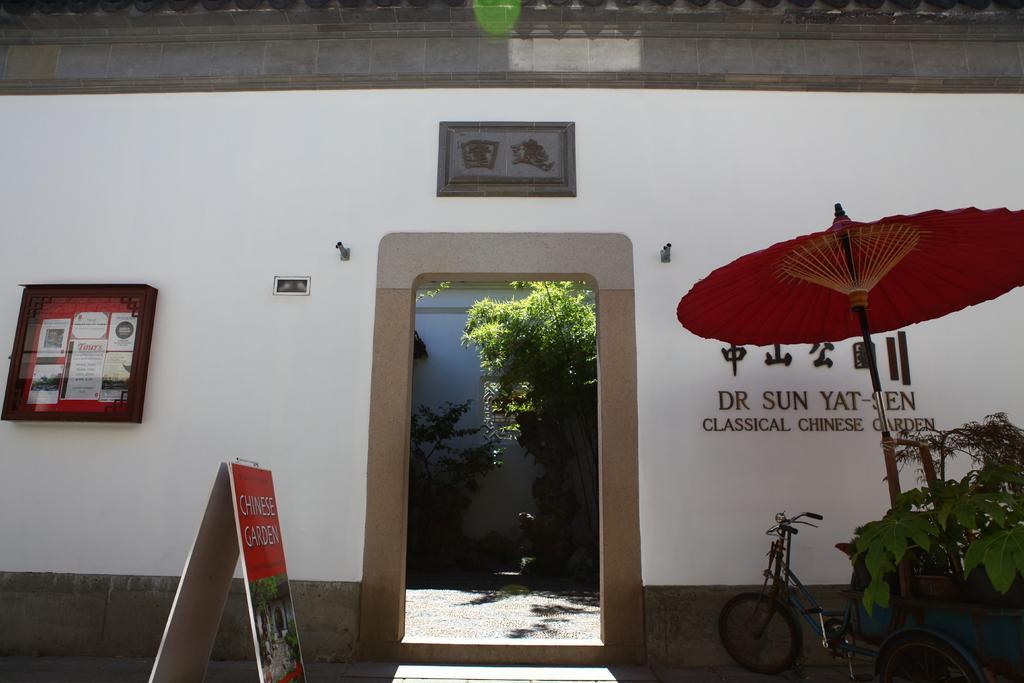Describe this image in one or two sentences. On the left side of the image we can see a wall, a board and a notice board. In the middle of the image we can see a entrance and trees. On the right side of the image we can see a bicycle, some text on the wall and a plant. 